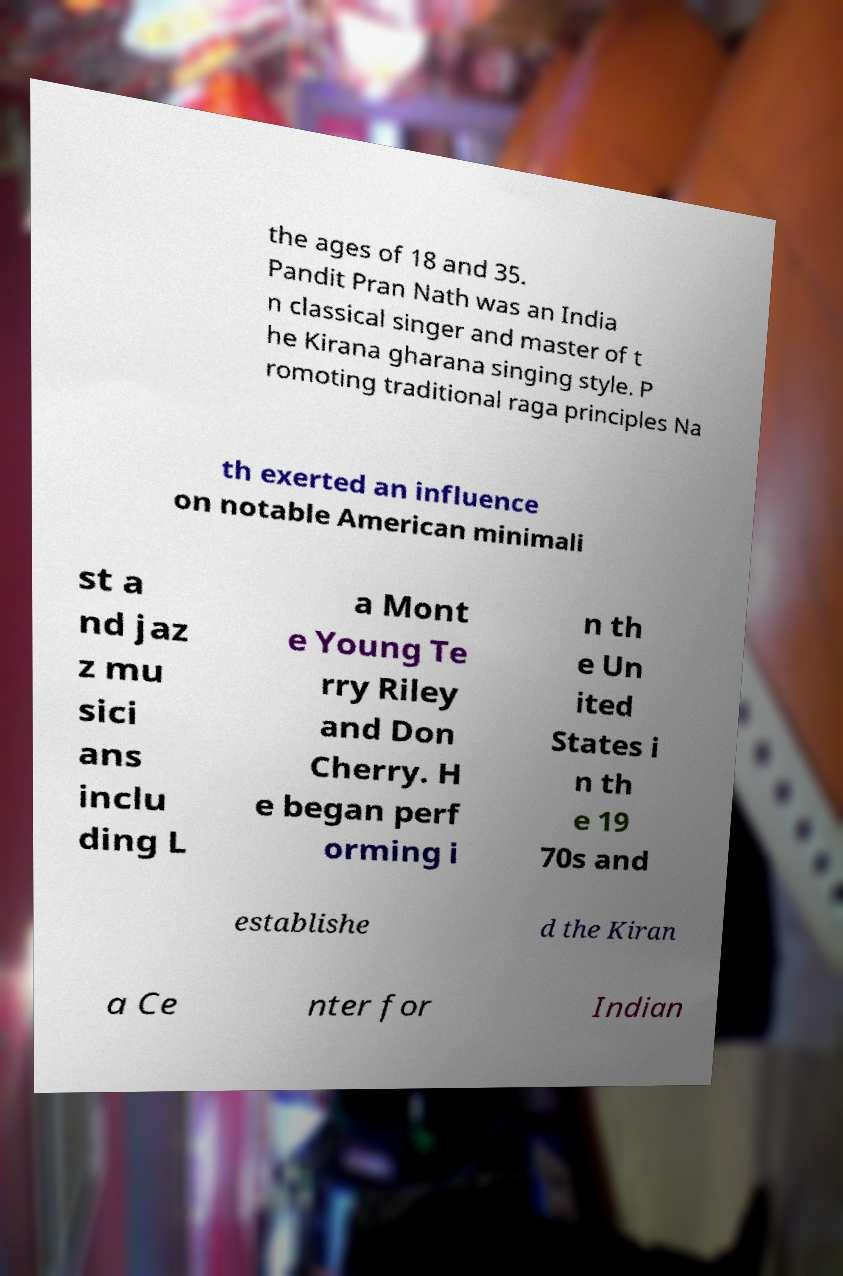Can you read and provide the text displayed in the image?This photo seems to have some interesting text. Can you extract and type it out for me? the ages of 18 and 35. Pandit Pran Nath was an India n classical singer and master of t he Kirana gharana singing style. P romoting traditional raga principles Na th exerted an influence on notable American minimali st a nd jaz z mu sici ans inclu ding L a Mont e Young Te rry Riley and Don Cherry. H e began perf orming i n th e Un ited States i n th e 19 70s and establishe d the Kiran a Ce nter for Indian 